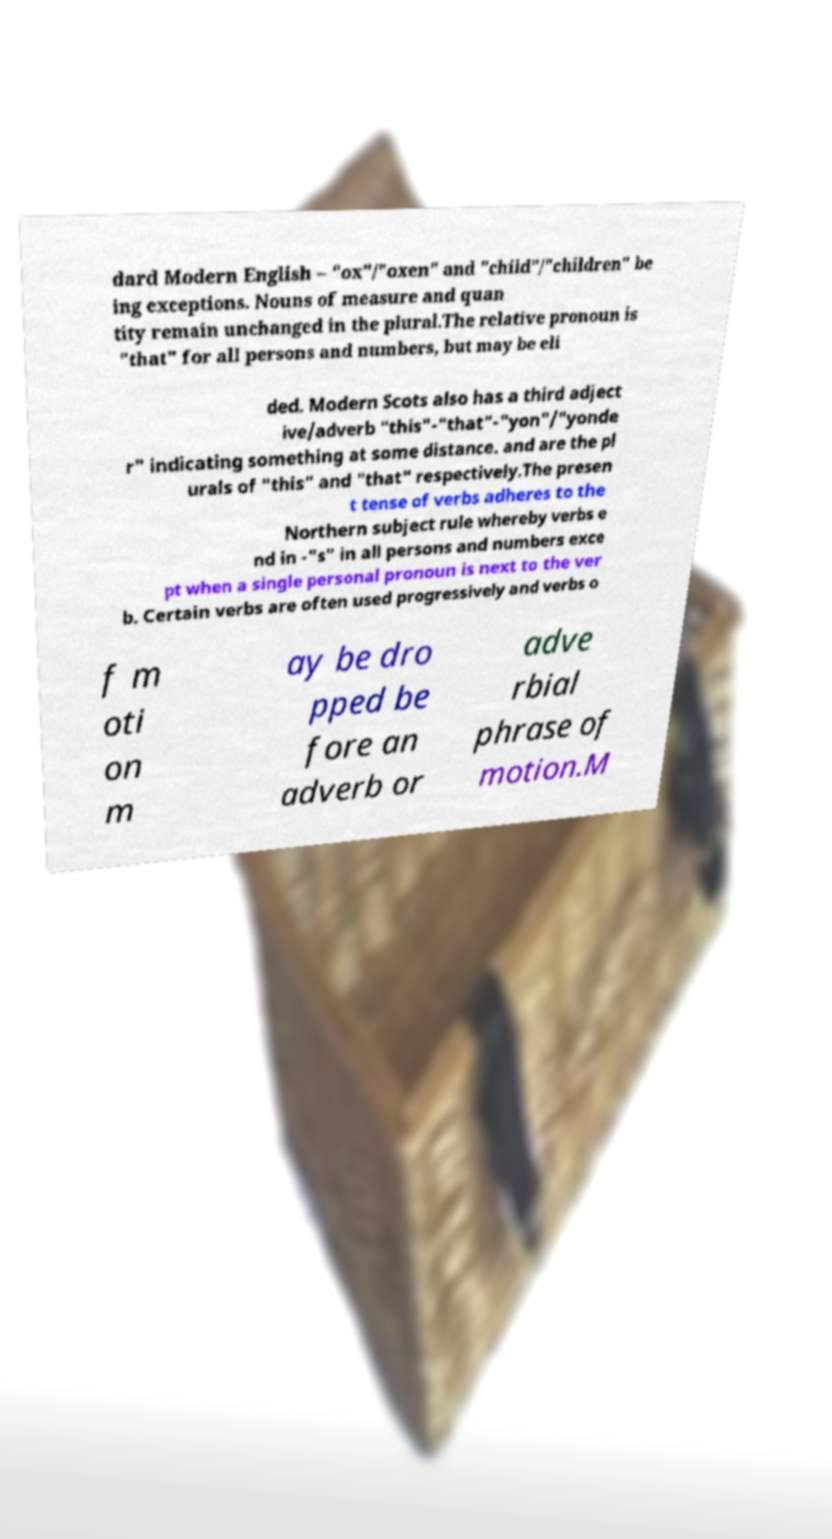I need the written content from this picture converted into text. Can you do that? dard Modern English – "ox"/"oxen" and "child"/"children" be ing exceptions. Nouns of measure and quan tity remain unchanged in the plural.The relative pronoun is "that" for all persons and numbers, but may be eli ded. Modern Scots also has a third adject ive/adverb "this"-"that"-"yon"/"yonde r" indicating something at some distance. and are the pl urals of "this" and "that" respectively.The presen t tense of verbs adheres to the Northern subject rule whereby verbs e nd in -"s" in all persons and numbers exce pt when a single personal pronoun is next to the ver b. Certain verbs are often used progressively and verbs o f m oti on m ay be dro pped be fore an adverb or adve rbial phrase of motion.M 